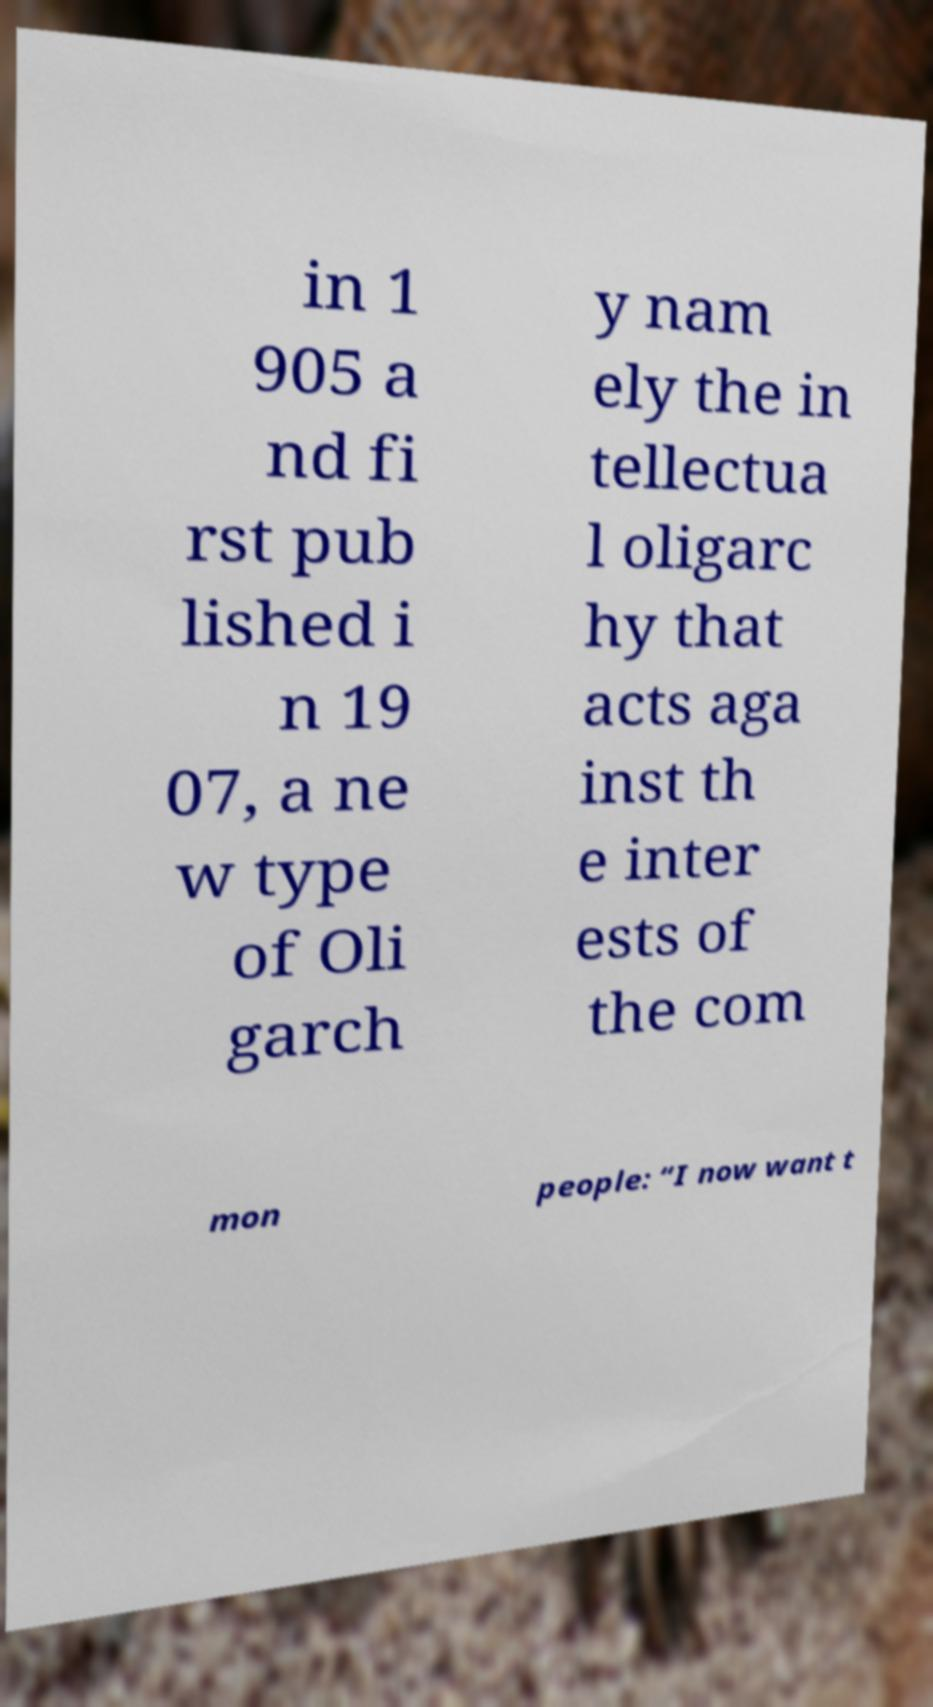Can you accurately transcribe the text from the provided image for me? in 1 905 a nd fi rst pub lished i n 19 07, a ne w type of Oli garch y nam ely the in tellectua l oligarc hy that acts aga inst th e inter ests of the com mon people: “I now want t 